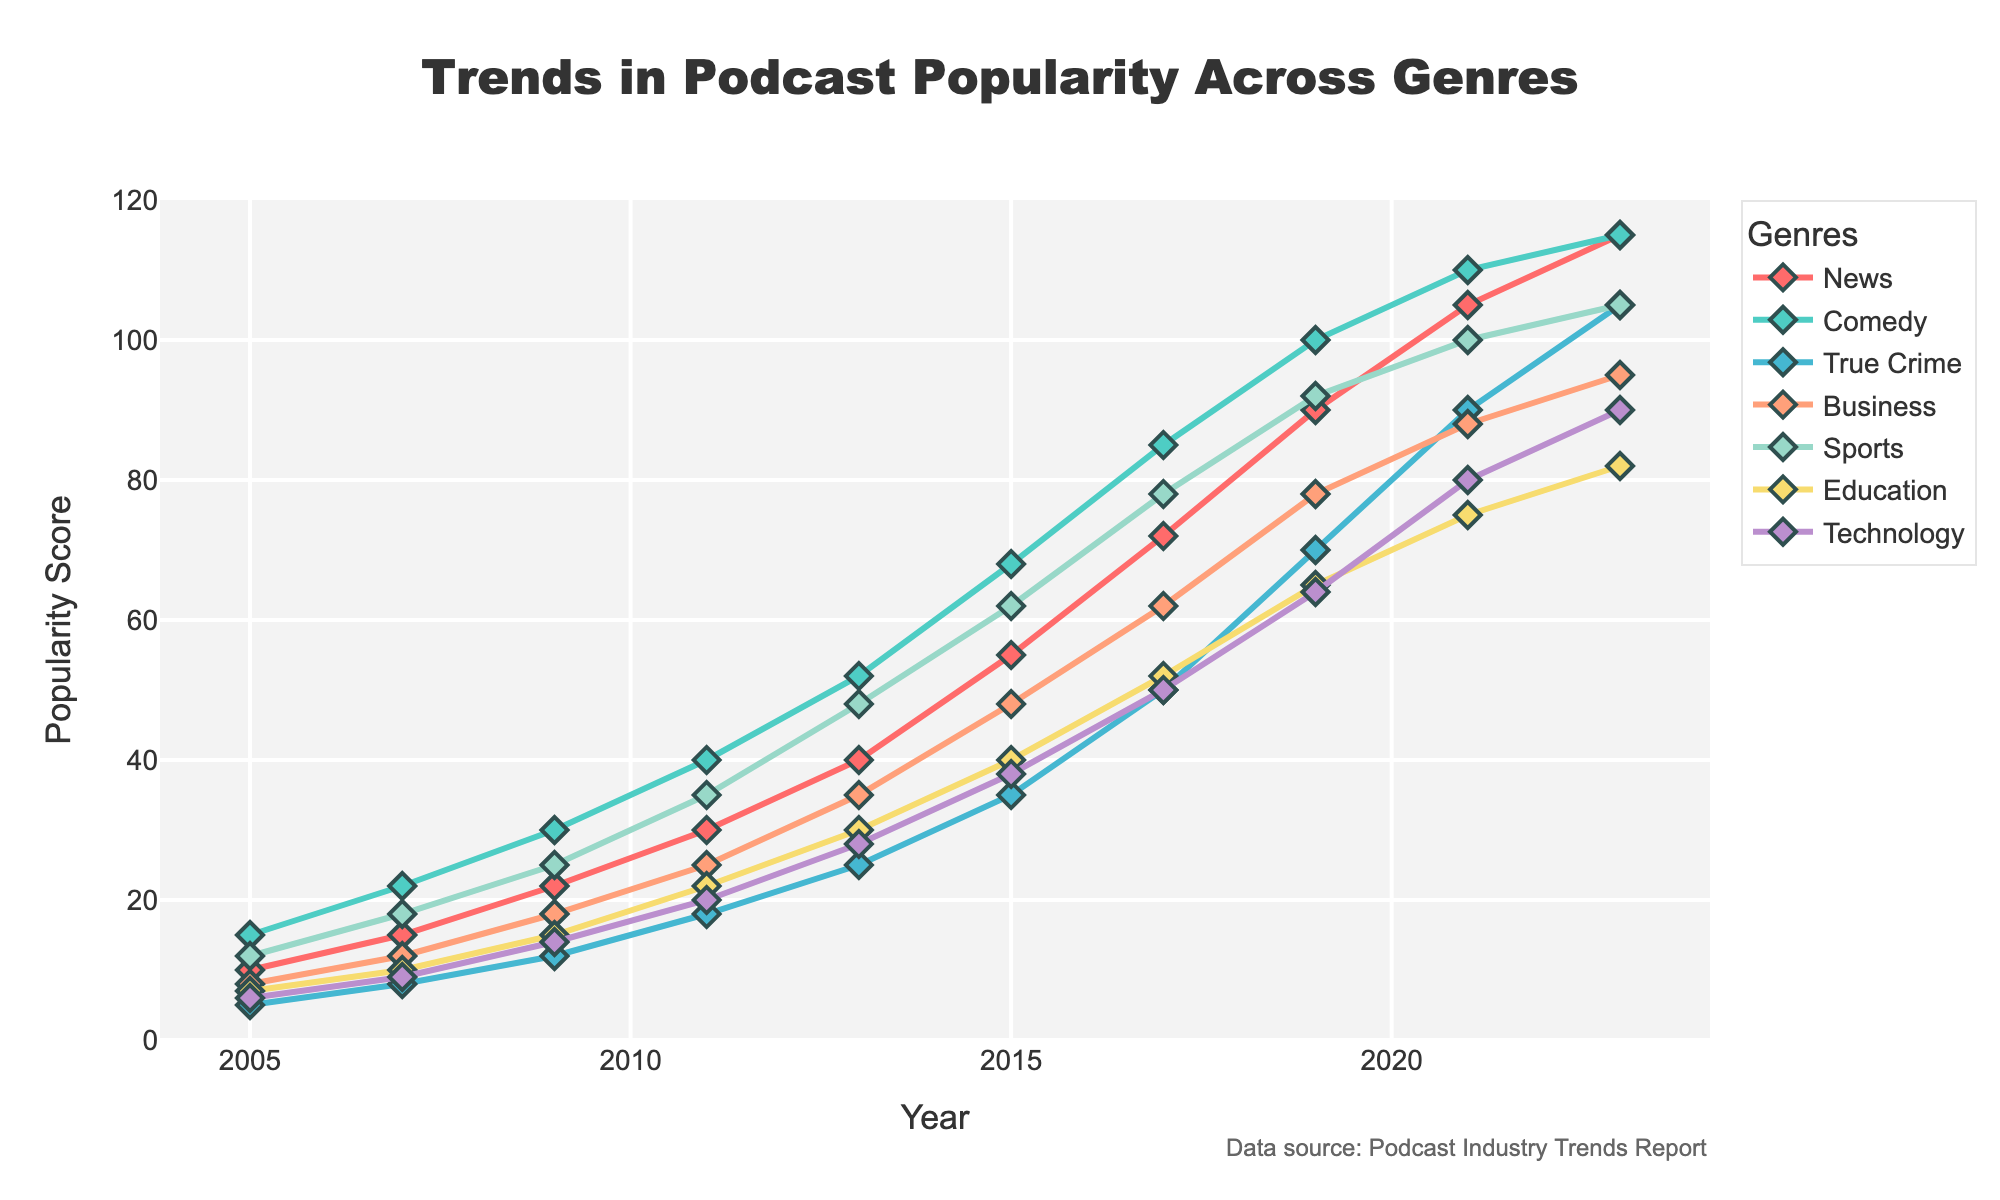What genre saw the highest rise in popularity from 2005 to 2023? To find the genre with the highest rise, we need to calculate the difference between the 2023 and 2005 popularity scores for each genre. The genre with the largest difference is the answer.
Answer: Comedy Which genre had the lowest popularity in 2023? By looking at the figure, the genre with the smallest popularity score in 2023 is the answer.
Answer: Technology Which genre had the steepest increase in popularity between 2017 and 2019? To find the steepest increase, calculate the difference for each genre between 2017 and 2019. The genre with the largest increase is the answer.
Answer: True Crime Which genre had relatively consistent growth over the years? By observing the trend lines, the genre with a nearly straight and smooth upward line shows consistent growth.
Answer: Education What is the combined popularity score of News and Comedy in 2023? Sum the popularity scores of News and Comedy for the year 2023 from the figure.
Answer: 230 Which year saw the highest popularity for True Crime relative to all other genres? Compare the True Crime popularity score with the other genres' scores year by year to find the year when True Crime was relatively the highest.
Answer: 2023 Between 2015 and 2017, which genre saw a larger increase, Business or Sports? Calculate the increase for both Business and Sports between 2015 and 2017. Compare the differences to determine which genre had the larger increase.
Answer: Sports What is the average popularity score of Education between 2005 and 2023? Sum the popularity scores for Education over the years from 2005 to 2023 and divide by the number of years.
Answer: 39.6 Visually, which genre uses a green color in its trend line? Identify the genre by looking at the green color-coded trend line in the chart.
Answer: Comedy In which year did Technology first surpass 50 in popularity score? Find the year in the chart where the Technology trend line first crosses the 50 mark.
Answer: 2017 